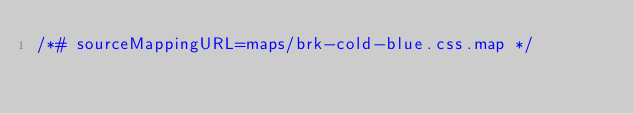Convert code to text. <code><loc_0><loc_0><loc_500><loc_500><_CSS_>/*# sourceMappingURL=maps/brk-cold-blue.css.map */
</code> 